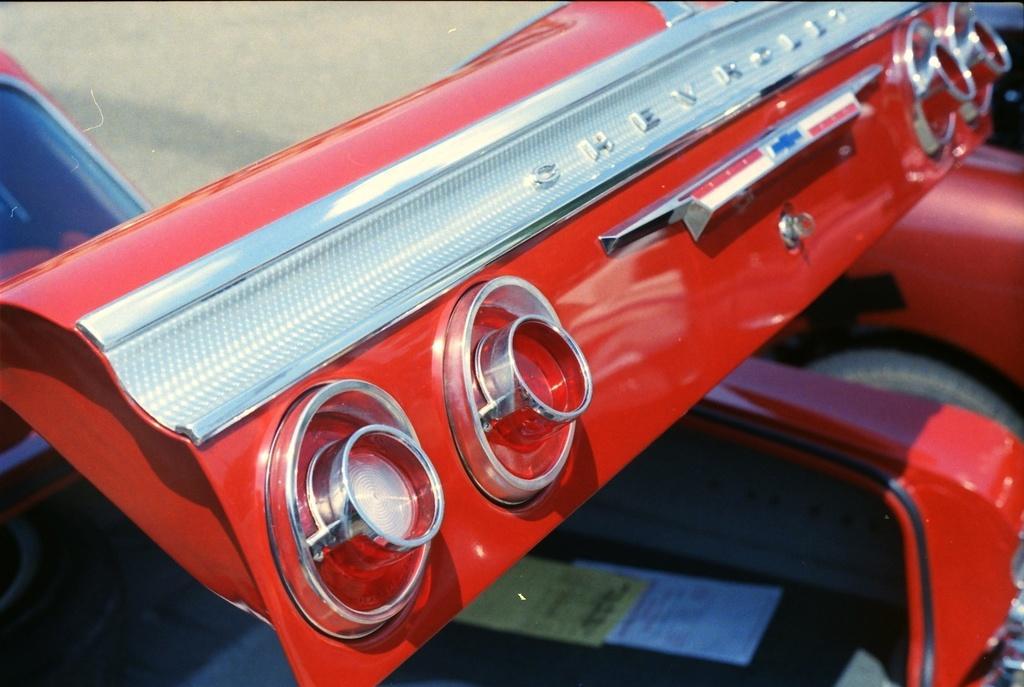Could you give a brief overview of what you see in this image? Here I can see a part of the car. Here I can see four lights to this. At the bottom of the image I can see few papers are placed in the car. This car is in red color. 